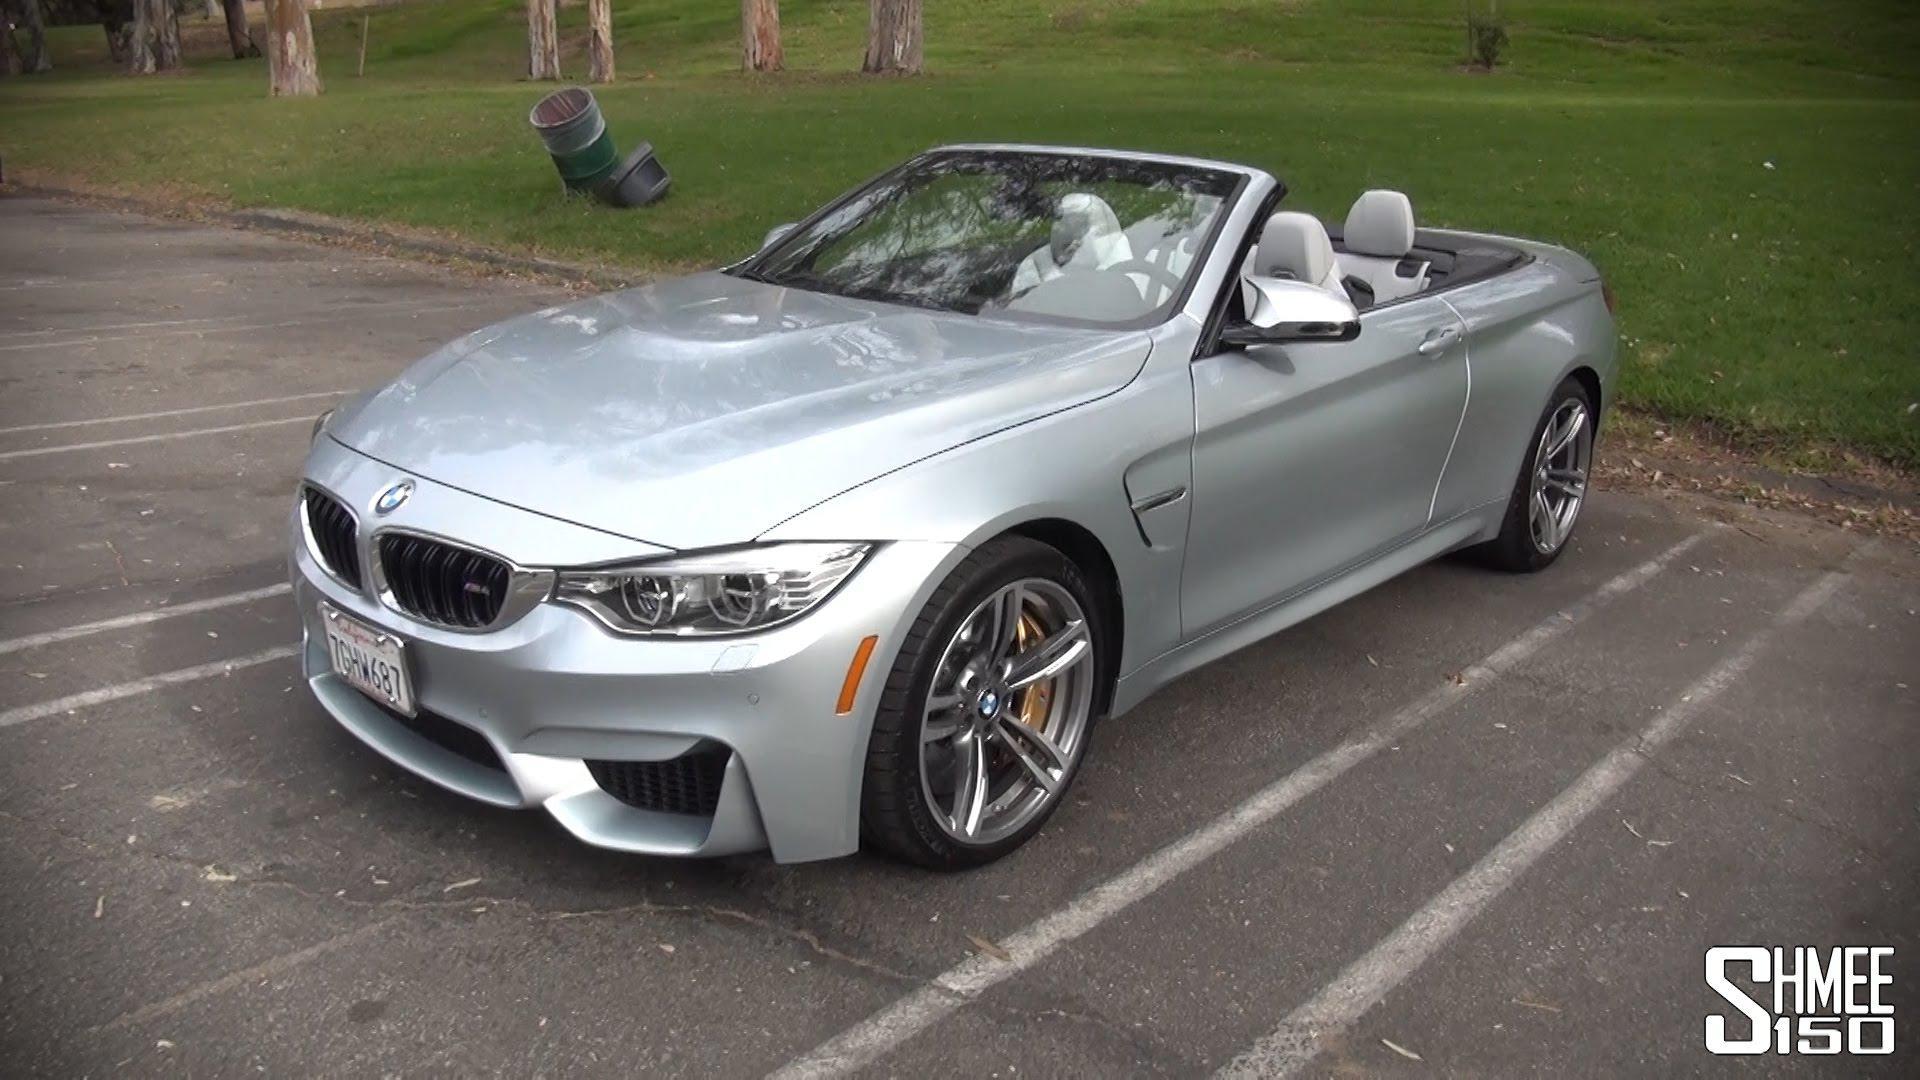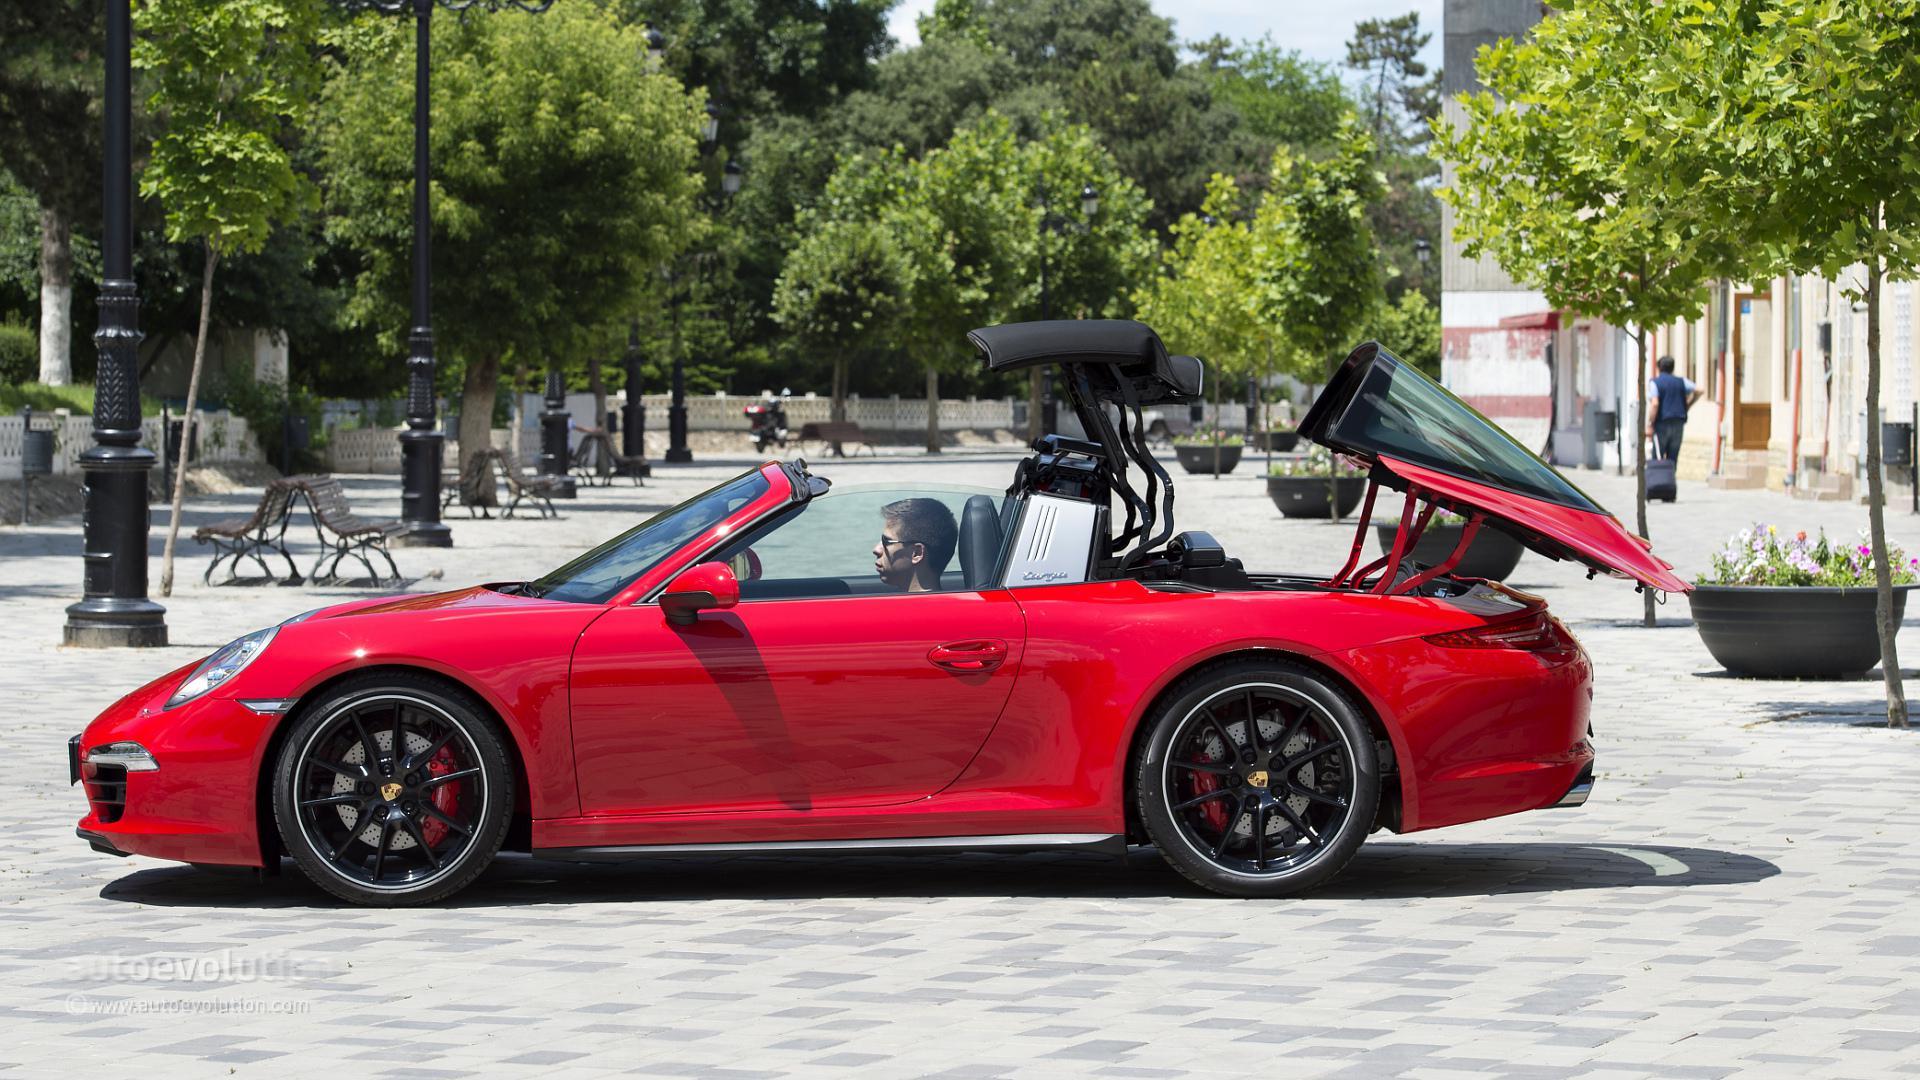The first image is the image on the left, the second image is the image on the right. Examine the images to the left and right. Is the description "The right image contains at least one red sports car." accurate? Answer yes or no. Yes. The first image is the image on the left, the second image is the image on the right. For the images shown, is this caption "Right and left images each contain a convertible in side view with its top partly raised." true? Answer yes or no. No. 